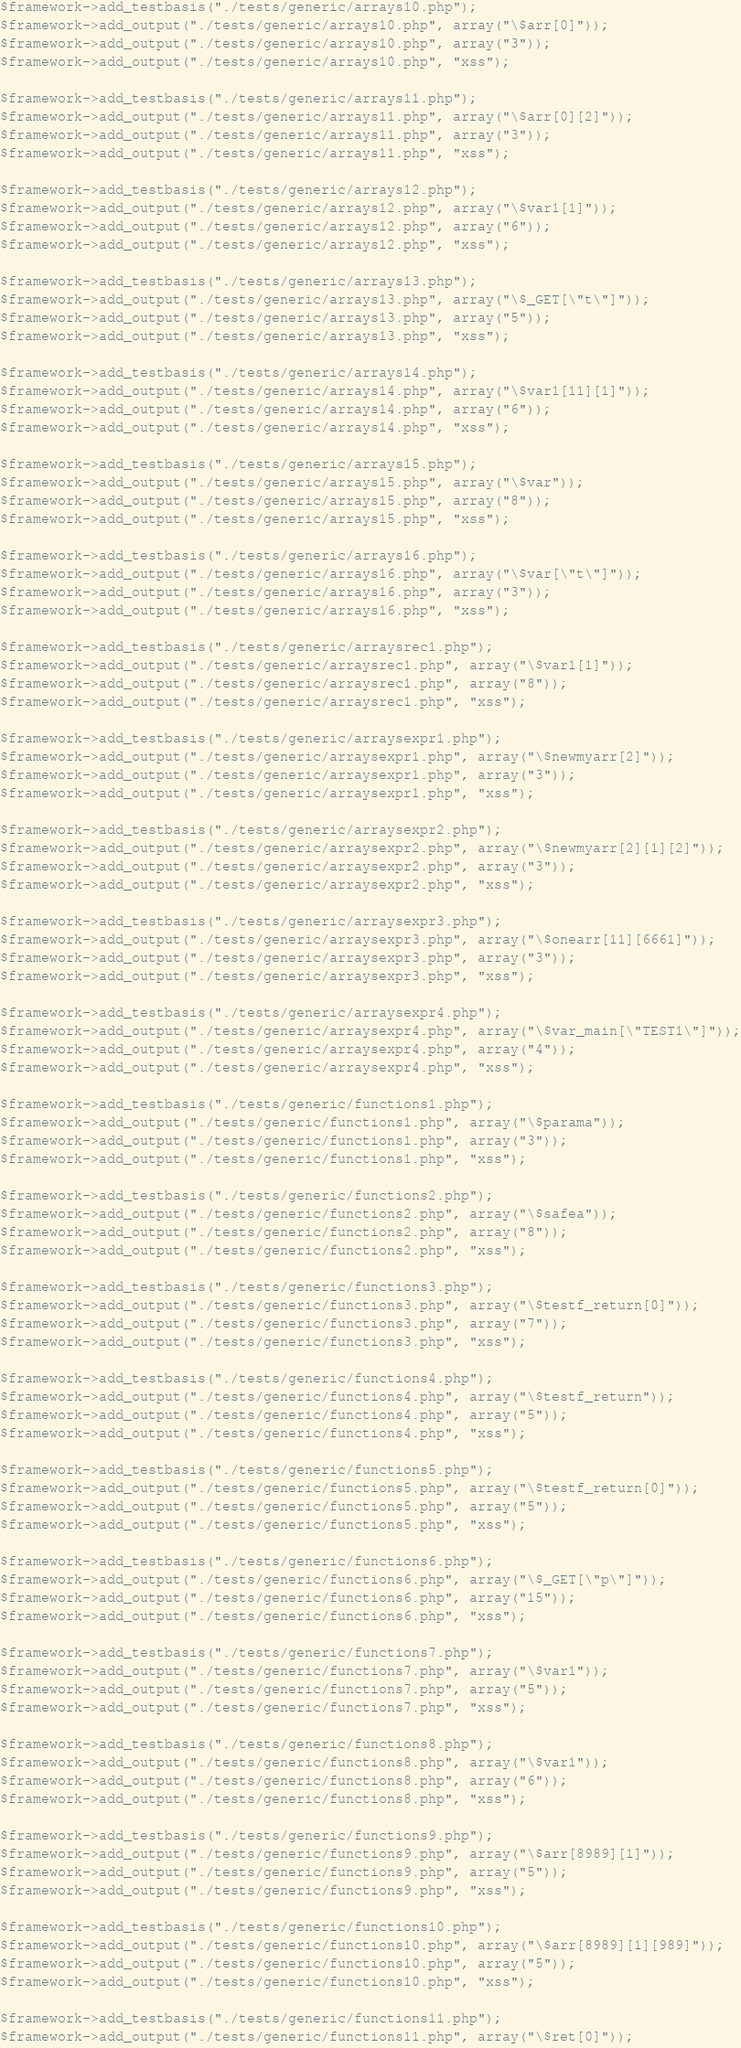Convert code to text. <code><loc_0><loc_0><loc_500><loc_500><_PHP_>
$framework->add_testbasis("./tests/generic/arrays10.php");
$framework->add_output("./tests/generic/arrays10.php", array("\$arr[0]"));
$framework->add_output("./tests/generic/arrays10.php", array("3"));
$framework->add_output("./tests/generic/arrays10.php", "xss");

$framework->add_testbasis("./tests/generic/arrays11.php");
$framework->add_output("./tests/generic/arrays11.php", array("\$arr[0][2]"));
$framework->add_output("./tests/generic/arrays11.php", array("3"));
$framework->add_output("./tests/generic/arrays11.php", "xss");

$framework->add_testbasis("./tests/generic/arrays12.php");
$framework->add_output("./tests/generic/arrays12.php", array("\$var1[1]"));
$framework->add_output("./tests/generic/arrays12.php", array("6"));
$framework->add_output("./tests/generic/arrays12.php", "xss");

$framework->add_testbasis("./tests/generic/arrays13.php");
$framework->add_output("./tests/generic/arrays13.php", array("\$_GET[\"t\"]"));
$framework->add_output("./tests/generic/arrays13.php", array("5"));
$framework->add_output("./tests/generic/arrays13.php", "xss");

$framework->add_testbasis("./tests/generic/arrays14.php");
$framework->add_output("./tests/generic/arrays14.php", array("\$var1[11][1]"));
$framework->add_output("./tests/generic/arrays14.php", array("6"));
$framework->add_output("./tests/generic/arrays14.php", "xss");

$framework->add_testbasis("./tests/generic/arrays15.php");
$framework->add_output("./tests/generic/arrays15.php", array("\$var"));
$framework->add_output("./tests/generic/arrays15.php", array("8"));
$framework->add_output("./tests/generic/arrays15.php", "xss");

$framework->add_testbasis("./tests/generic/arrays16.php");
$framework->add_output("./tests/generic/arrays16.php", array("\$var[\"t\"]"));
$framework->add_output("./tests/generic/arrays16.php", array("3"));
$framework->add_output("./tests/generic/arrays16.php", "xss");

$framework->add_testbasis("./tests/generic/arraysrec1.php");
$framework->add_output("./tests/generic/arraysrec1.php", array("\$var1[1]"));
$framework->add_output("./tests/generic/arraysrec1.php", array("8"));
$framework->add_output("./tests/generic/arraysrec1.php", "xss");

$framework->add_testbasis("./tests/generic/arraysexpr1.php");
$framework->add_output("./tests/generic/arraysexpr1.php", array("\$newmyarr[2]"));
$framework->add_output("./tests/generic/arraysexpr1.php", array("3"));
$framework->add_output("./tests/generic/arraysexpr1.php", "xss");

$framework->add_testbasis("./tests/generic/arraysexpr2.php");
$framework->add_output("./tests/generic/arraysexpr2.php", array("\$newmyarr[2][1][2]"));
$framework->add_output("./tests/generic/arraysexpr2.php", array("3"));
$framework->add_output("./tests/generic/arraysexpr2.php", "xss");

$framework->add_testbasis("./tests/generic/arraysexpr3.php");
$framework->add_output("./tests/generic/arraysexpr3.php", array("\$onearr[11][6661]"));
$framework->add_output("./tests/generic/arraysexpr3.php", array("3"));
$framework->add_output("./tests/generic/arraysexpr3.php", "xss");

$framework->add_testbasis("./tests/generic/arraysexpr4.php");
$framework->add_output("./tests/generic/arraysexpr4.php", array("\$var_main[\"TEST1\"]"));
$framework->add_output("./tests/generic/arraysexpr4.php", array("4"));
$framework->add_output("./tests/generic/arraysexpr4.php", "xss");

$framework->add_testbasis("./tests/generic/functions1.php");
$framework->add_output("./tests/generic/functions1.php", array("\$parama"));
$framework->add_output("./tests/generic/functions1.php", array("3"));
$framework->add_output("./tests/generic/functions1.php", "xss");

$framework->add_testbasis("./tests/generic/functions2.php");
$framework->add_output("./tests/generic/functions2.php", array("\$safea"));
$framework->add_output("./tests/generic/functions2.php", array("8"));
$framework->add_output("./tests/generic/functions2.php", "xss");

$framework->add_testbasis("./tests/generic/functions3.php");
$framework->add_output("./tests/generic/functions3.php", array("\$testf_return[0]"));
$framework->add_output("./tests/generic/functions3.php", array("7"));
$framework->add_output("./tests/generic/functions3.php", "xss");

$framework->add_testbasis("./tests/generic/functions4.php");
$framework->add_output("./tests/generic/functions4.php", array("\$testf_return"));
$framework->add_output("./tests/generic/functions4.php", array("5"));
$framework->add_output("./tests/generic/functions4.php", "xss");

$framework->add_testbasis("./tests/generic/functions5.php");
$framework->add_output("./tests/generic/functions5.php", array("\$testf_return[0]"));
$framework->add_output("./tests/generic/functions5.php", array("5"));
$framework->add_output("./tests/generic/functions5.php", "xss");

$framework->add_testbasis("./tests/generic/functions6.php");
$framework->add_output("./tests/generic/functions6.php", array("\$_GET[\"p\"]"));
$framework->add_output("./tests/generic/functions6.php", array("15"));
$framework->add_output("./tests/generic/functions6.php", "xss");

$framework->add_testbasis("./tests/generic/functions7.php");
$framework->add_output("./tests/generic/functions7.php", array("\$var1"));
$framework->add_output("./tests/generic/functions7.php", array("5"));
$framework->add_output("./tests/generic/functions7.php", "xss");

$framework->add_testbasis("./tests/generic/functions8.php");
$framework->add_output("./tests/generic/functions8.php", array("\$var1"));
$framework->add_output("./tests/generic/functions8.php", array("6"));
$framework->add_output("./tests/generic/functions8.php", "xss");

$framework->add_testbasis("./tests/generic/functions9.php");
$framework->add_output("./tests/generic/functions9.php", array("\$arr[8989][1]"));
$framework->add_output("./tests/generic/functions9.php", array("5"));
$framework->add_output("./tests/generic/functions9.php", "xss");

$framework->add_testbasis("./tests/generic/functions10.php");
$framework->add_output("./tests/generic/functions10.php", array("\$arr[8989][1][989]"));
$framework->add_output("./tests/generic/functions10.php", array("5"));
$framework->add_output("./tests/generic/functions10.php", "xss");

$framework->add_testbasis("./tests/generic/functions11.php");
$framework->add_output("./tests/generic/functions11.php", array("\$ret[0]"));</code> 